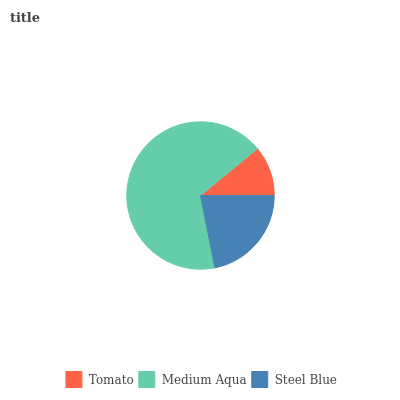Is Tomato the minimum?
Answer yes or no. Yes. Is Medium Aqua the maximum?
Answer yes or no. Yes. Is Steel Blue the minimum?
Answer yes or no. No. Is Steel Blue the maximum?
Answer yes or no. No. Is Medium Aqua greater than Steel Blue?
Answer yes or no. Yes. Is Steel Blue less than Medium Aqua?
Answer yes or no. Yes. Is Steel Blue greater than Medium Aqua?
Answer yes or no. No. Is Medium Aqua less than Steel Blue?
Answer yes or no. No. Is Steel Blue the high median?
Answer yes or no. Yes. Is Steel Blue the low median?
Answer yes or no. Yes. Is Tomato the high median?
Answer yes or no. No. Is Medium Aqua the low median?
Answer yes or no. No. 